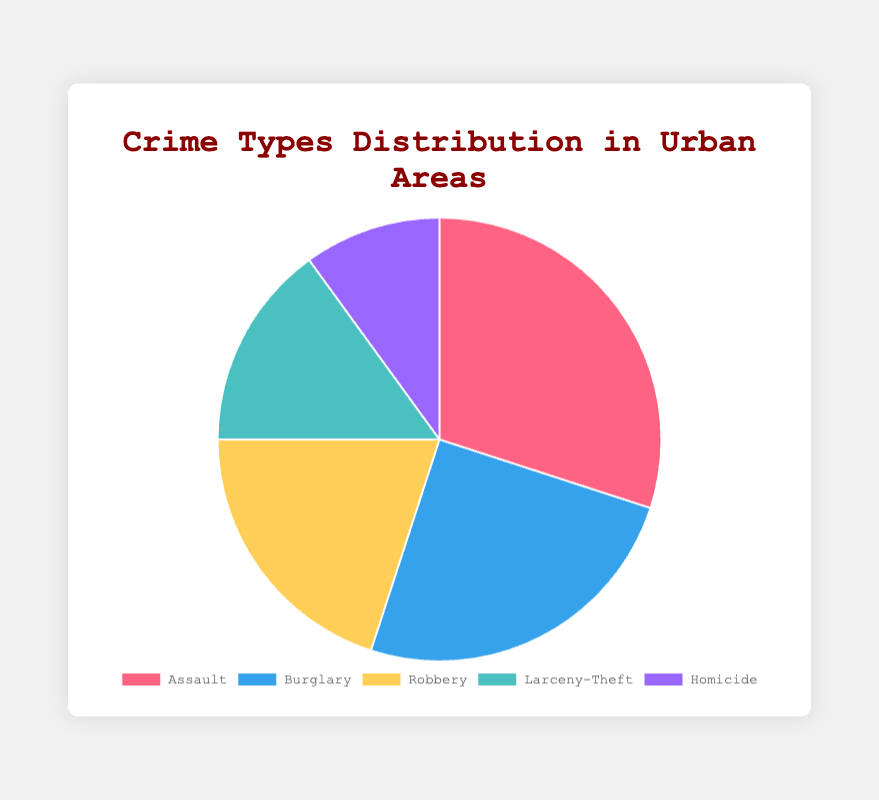What percentage of crimes are property crimes (Burglary and Larceny-Theft)? Add the percentages for Burglary (25%) and Larceny-Theft (15%), which are classified as property crimes. 25% + 15% = 40%
Answer: 40% Which crime type has the smallest percentage? The pie chart shows the percentages for each crime type. Homicide has the smallest percentage at 10%.
Answer: Homicide How does the percentage of Assault compare to the percentage of Burglary? Assault is 30%, and Burglary is 25%. 30% is greater than 25%.
Answer: Assault is greater What is the combined percentage of violent crimes (Assault, Robbery, and Homicide)? Add the percentages for Assault (30%), Robbery (20%), and Homicide (10%), which are classified as violent crimes. 30% + 20% + 10% = 60%
Answer: 60% Which two crime types together make up 45% of the total crimes? By examining the pie chart, we see that Robbery (20%) and Larceny-Theft (15%) together make up 20% + 15% = 35%, and Burglary (25%) and Homicide (10%) together make up 25% + 10% = 35%. Therefore, it's Assault (30%) and Homicide (10%) together make up 30% + 10% = 40%. Thus, not confirmed through combinations to make up 45% by two .
Answer: N/A What is the difference in percentage between the most and least common crime types? The most common crime type is Assault (30%), and the least common is Homicide (10%). The difference is 30% - 10% = 20%.
Answer: 20% If the chart is updated such that Larceny-Theft increases by 5%, what will be the new percentage for Larceny-Theft? The original percentage for Larceny-Theft is 15%. Increasing this by 5% gives 15% + 5% = 20%.
Answer: 20% What crime type is represented by the blue section of the pie chart? By referring to the color scheme in the figure, Burglary is represented by the blue section.
Answer: Burglary Which crime types together constitute half of the pie chart? Assault (30%) and Burglary (25%) together constitute 30% + 25% = 55%, so they make up more than half. Instead, Assault and Robbery (30% + 20%) constitute 50% of the chart.
Answer: Assault and Robbery 